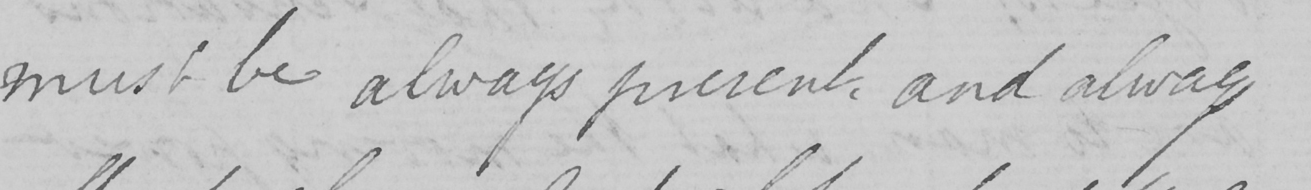What is written in this line of handwriting? must be always present , and always 